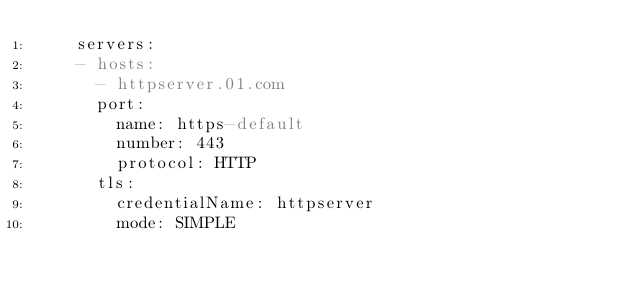<code> <loc_0><loc_0><loc_500><loc_500><_YAML_>    servers:
    - hosts:
      - httpserver.01.com
      port:
        name: https-default
        number: 443
        protocol: HTTP
      tls:
        credentialName: httpserver
        mode: SIMPLE
</code> 